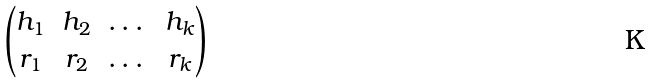<formula> <loc_0><loc_0><loc_500><loc_500>\begin{pmatrix} h _ { 1 } & h _ { 2 } & \dots & h _ { k } \\ r _ { 1 } & r _ { 2 } & \dots & r _ { k } \end{pmatrix}</formula> 